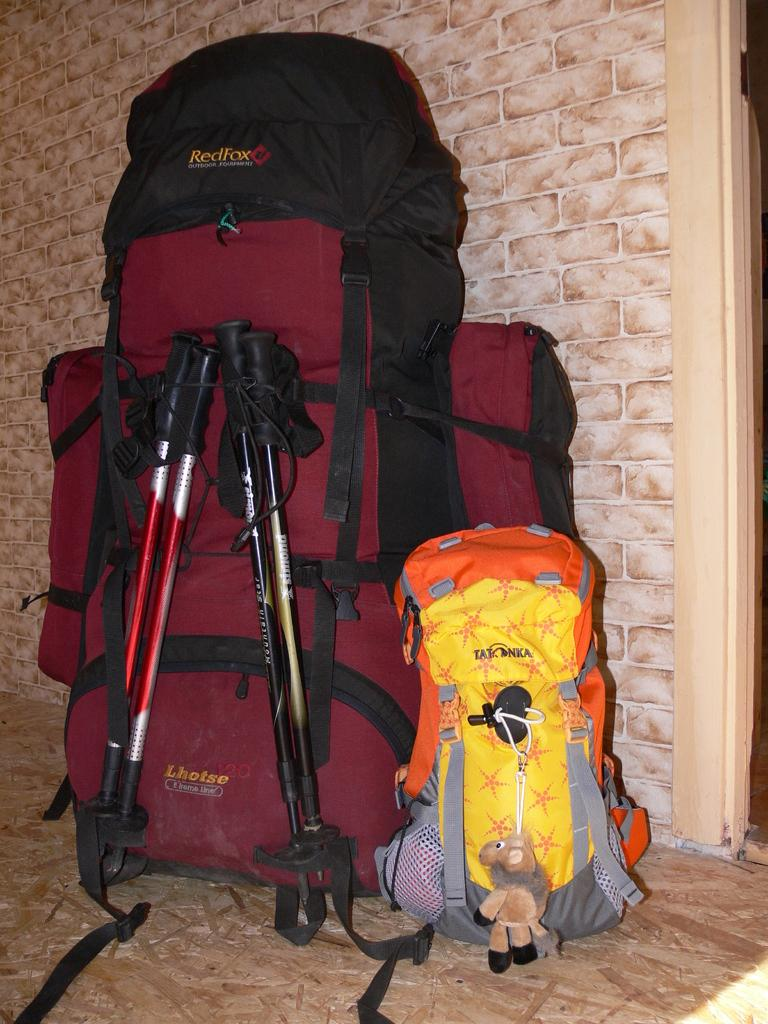<image>
Give a short and clear explanation of the subsequent image. a lhotse and tat onka backpack with ski poles 